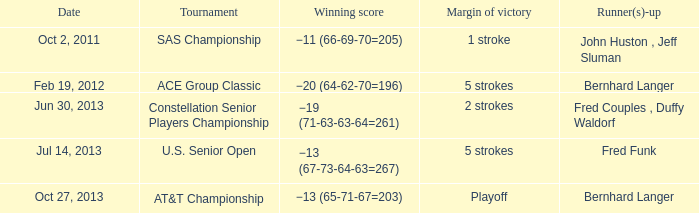In which date did the at&t championship take place with bernhard langer as one of the runner(s)-up? Oct 27, 2013. 